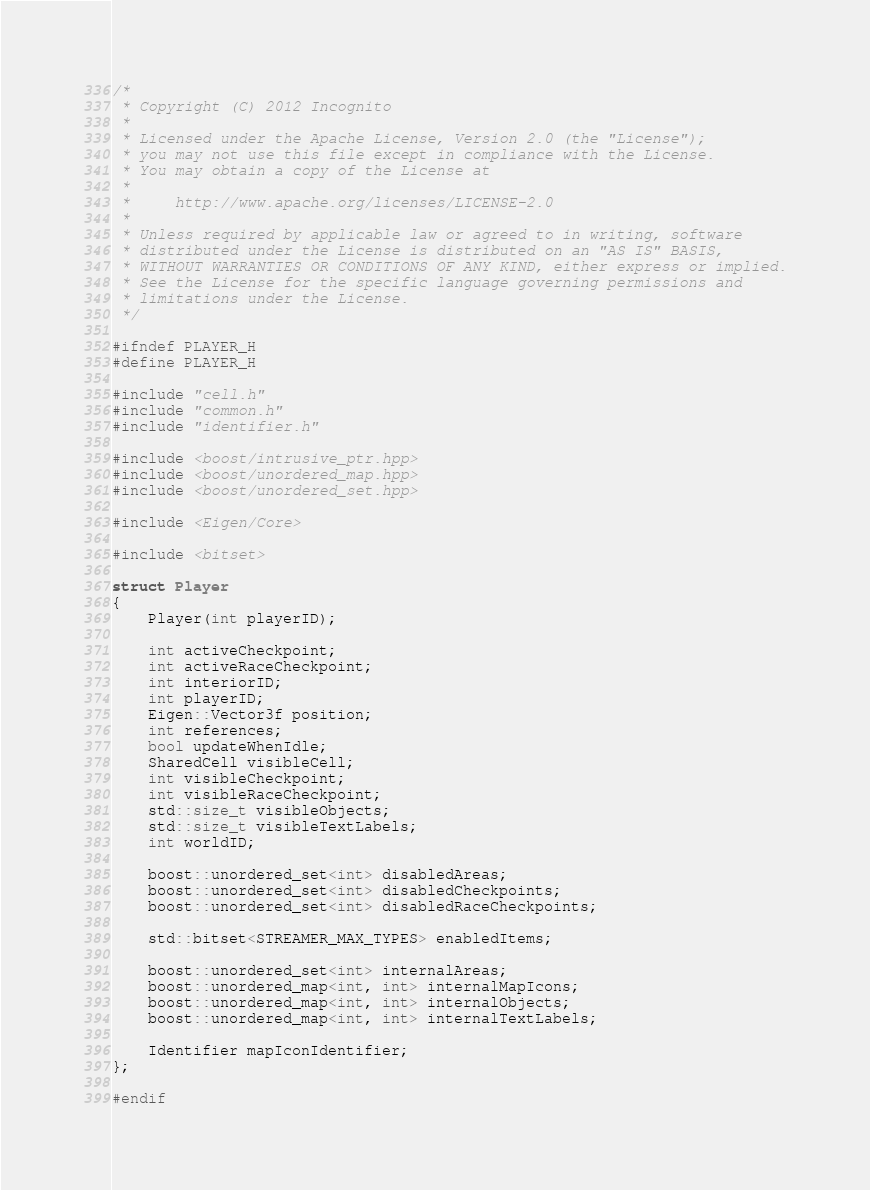Convert code to text. <code><loc_0><loc_0><loc_500><loc_500><_C_>/*
 * Copyright (C) 2012 Incognito
 *
 * Licensed under the Apache License, Version 2.0 (the "License");
 * you may not use this file except in compliance with the License.
 * You may obtain a copy of the License at
 *
 *     http://www.apache.org/licenses/LICENSE-2.0
 *
 * Unless required by applicable law or agreed to in writing, software
 * distributed under the License is distributed on an "AS IS" BASIS,
 * WITHOUT WARRANTIES OR CONDITIONS OF ANY KIND, either express or implied.
 * See the License for the specific language governing permissions and
 * limitations under the License.
 */

#ifndef PLAYER_H
#define PLAYER_H

#include "cell.h"
#include "common.h"
#include "identifier.h"

#include <boost/intrusive_ptr.hpp>
#include <boost/unordered_map.hpp>
#include <boost/unordered_set.hpp>

#include <Eigen/Core>

#include <bitset>

struct Player
{
	Player(int playerID);

	int activeCheckpoint;
	int activeRaceCheckpoint;
	int interiorID;
	int playerID;
	Eigen::Vector3f position;
	int references;
	bool updateWhenIdle;
	SharedCell visibleCell;
	int visibleCheckpoint;
	int visibleRaceCheckpoint;
	std::size_t visibleObjects;
	std::size_t visibleTextLabels;
	int worldID;

	boost::unordered_set<int> disabledAreas;
	boost::unordered_set<int> disabledCheckpoints;
	boost::unordered_set<int> disabledRaceCheckpoints;

	std::bitset<STREAMER_MAX_TYPES> enabledItems;

	boost::unordered_set<int> internalAreas;
	boost::unordered_map<int, int> internalMapIcons;
	boost::unordered_map<int, int> internalObjects;
	boost::unordered_map<int, int> internalTextLabels;

	Identifier mapIconIdentifier;
};

#endif
</code> 